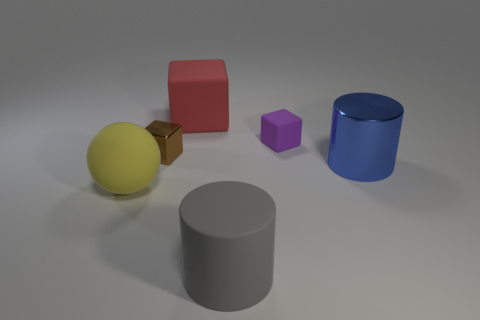What number of other things are the same material as the small purple block?
Make the answer very short. 3. How many things are on the right side of the big yellow rubber object and to the left of the large blue cylinder?
Your answer should be very brief. 4. Is the size of the rubber sphere the same as the metal thing that is in front of the brown metal object?
Your answer should be very brief. Yes. Is there a large rubber ball behind the rubber object that is to the right of the rubber thing that is in front of the sphere?
Offer a terse response. No. There is a large cylinder left of the big cylinder behind the yellow thing; what is its material?
Ensure brevity in your answer.  Rubber. What is the thing that is both on the right side of the large block and behind the brown shiny object made of?
Give a very brief answer. Rubber. Is there a red matte object that has the same shape as the yellow matte thing?
Offer a terse response. No. Is there a purple object that is left of the tiny cube that is on the left side of the purple matte object?
Your answer should be compact. No. How many brown objects are made of the same material as the large blue object?
Provide a short and direct response. 1. Are there any small red rubber blocks?
Make the answer very short. No. 